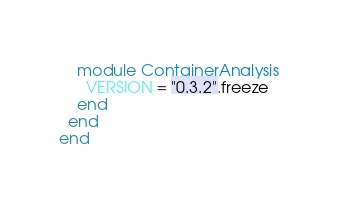<code> <loc_0><loc_0><loc_500><loc_500><_Ruby_>    module ContainerAnalysis
      VERSION = "0.3.2".freeze
    end
  end
end
</code> 